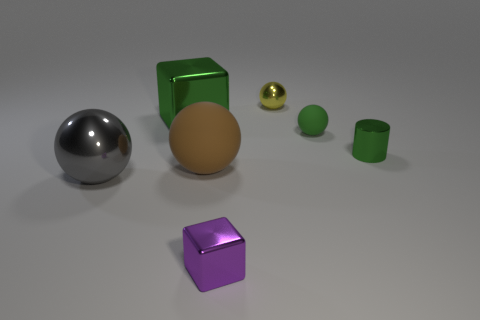Subtract all small green spheres. How many spheres are left? 3 Subtract all brown spheres. How many spheres are left? 3 Add 1 large brown metal spheres. How many objects exist? 8 Subtract all blue balls. Subtract all gray cubes. How many balls are left? 4 Subtract all cylinders. How many objects are left? 6 Add 2 purple metallic cubes. How many purple metallic cubes are left? 3 Add 4 green matte objects. How many green matte objects exist? 5 Subtract 0 purple spheres. How many objects are left? 7 Subtract all green matte objects. Subtract all large purple cubes. How many objects are left? 6 